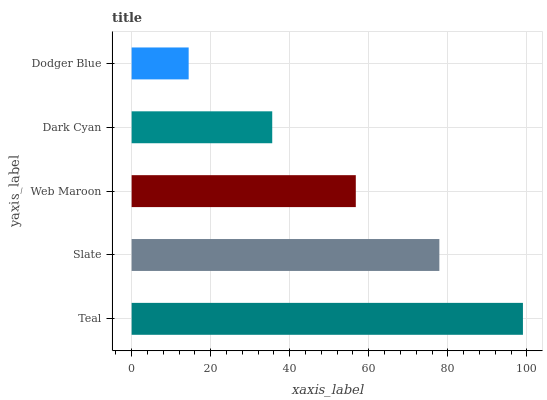Is Dodger Blue the minimum?
Answer yes or no. Yes. Is Teal the maximum?
Answer yes or no. Yes. Is Slate the minimum?
Answer yes or no. No. Is Slate the maximum?
Answer yes or no. No. Is Teal greater than Slate?
Answer yes or no. Yes. Is Slate less than Teal?
Answer yes or no. Yes. Is Slate greater than Teal?
Answer yes or no. No. Is Teal less than Slate?
Answer yes or no. No. Is Web Maroon the high median?
Answer yes or no. Yes. Is Web Maroon the low median?
Answer yes or no. Yes. Is Slate the high median?
Answer yes or no. No. Is Dark Cyan the low median?
Answer yes or no. No. 